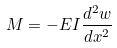Convert formula to latex. <formula><loc_0><loc_0><loc_500><loc_500>M = - E I \frac { d ^ { 2 } w } { d x ^ { 2 } }</formula> 